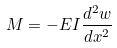Convert formula to latex. <formula><loc_0><loc_0><loc_500><loc_500>M = - E I \frac { d ^ { 2 } w } { d x ^ { 2 } }</formula> 